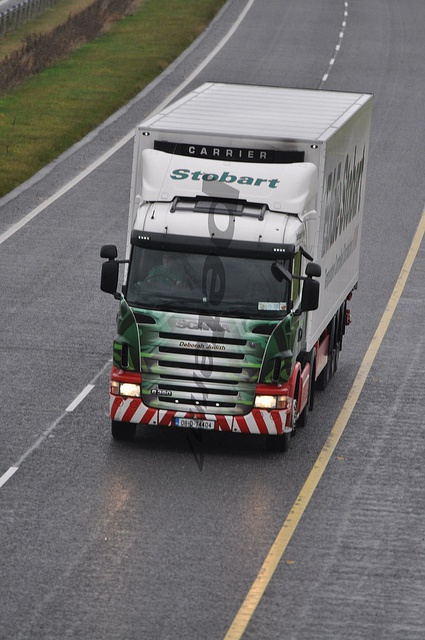Describe the objects in this image and their specific colors. I can see truck in gray, black, darkgray, and lightgray tones and people in gray, purple, and black tones in this image. 